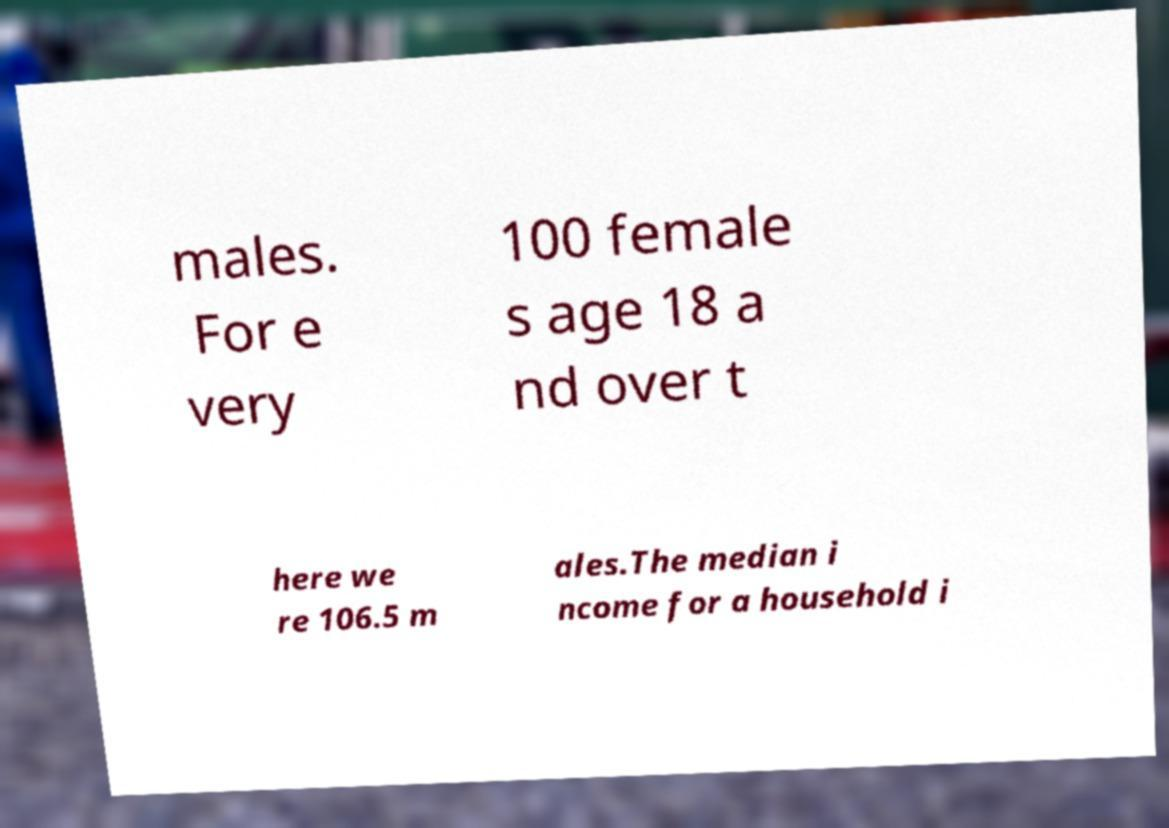What messages or text are displayed in this image? I need them in a readable, typed format. males. For e very 100 female s age 18 a nd over t here we re 106.5 m ales.The median i ncome for a household i 